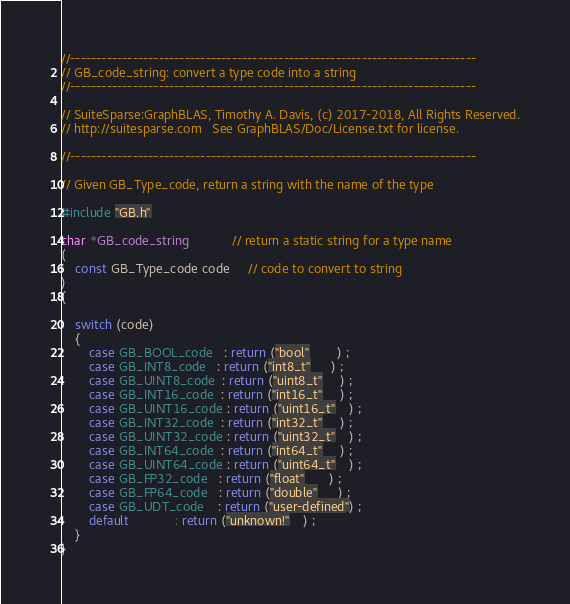Convert code to text. <code><loc_0><loc_0><loc_500><loc_500><_C_>//------------------------------------------------------------------------------
// GB_code_string: convert a type code into a string
//------------------------------------------------------------------------------

// SuiteSparse:GraphBLAS, Timothy A. Davis, (c) 2017-2018, All Rights Reserved.
// http://suitesparse.com   See GraphBLAS/Doc/License.txt for license.

//------------------------------------------------------------------------------

// Given GB_Type_code, return a string with the name of the type

#include "GB.h"

char *GB_code_string            // return a static string for a type name
(
    const GB_Type_code code     // code to convert to string
)
{

    switch (code)
    {
        case GB_BOOL_code   : return ("bool"        ) ;
        case GB_INT8_code   : return ("int8_t"      ) ;
        case GB_UINT8_code  : return ("uint8_t"     ) ;
        case GB_INT16_code  : return ("int16_t"     ) ;
        case GB_UINT16_code : return ("uint16_t"    ) ;
        case GB_INT32_code  : return ("int32_t"     ) ;
        case GB_UINT32_code : return ("uint32_t"    ) ;
        case GB_INT64_code  : return ("int64_t"     ) ;
        case GB_UINT64_code : return ("uint64_t"    ) ;
        case GB_FP32_code   : return ("float"       ) ;
        case GB_FP64_code   : return ("double"      ) ;
        case GB_UDT_code    : return ("user-defined") ;
        default             : return ("unknown!"    ) ;
    }
}

</code> 